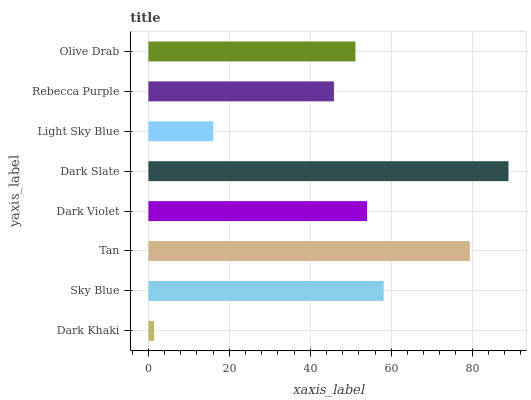Is Dark Khaki the minimum?
Answer yes or no. Yes. Is Dark Slate the maximum?
Answer yes or no. Yes. Is Sky Blue the minimum?
Answer yes or no. No. Is Sky Blue the maximum?
Answer yes or no. No. Is Sky Blue greater than Dark Khaki?
Answer yes or no. Yes. Is Dark Khaki less than Sky Blue?
Answer yes or no. Yes. Is Dark Khaki greater than Sky Blue?
Answer yes or no. No. Is Sky Blue less than Dark Khaki?
Answer yes or no. No. Is Dark Violet the high median?
Answer yes or no. Yes. Is Olive Drab the low median?
Answer yes or no. Yes. Is Olive Drab the high median?
Answer yes or no. No. Is Dark Khaki the low median?
Answer yes or no. No. 